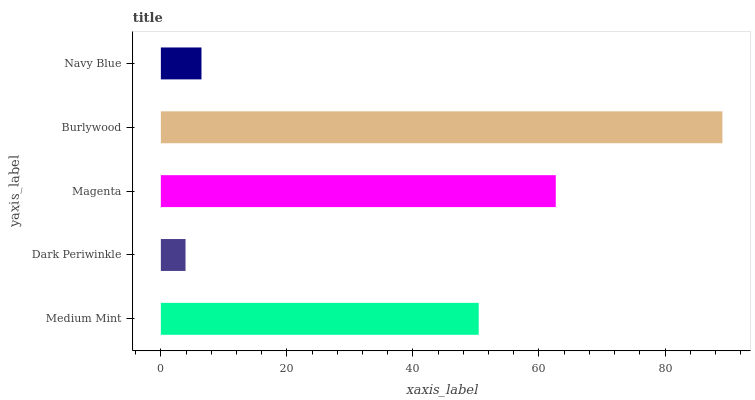Is Dark Periwinkle the minimum?
Answer yes or no. Yes. Is Burlywood the maximum?
Answer yes or no. Yes. Is Magenta the minimum?
Answer yes or no. No. Is Magenta the maximum?
Answer yes or no. No. Is Magenta greater than Dark Periwinkle?
Answer yes or no. Yes. Is Dark Periwinkle less than Magenta?
Answer yes or no. Yes. Is Dark Periwinkle greater than Magenta?
Answer yes or no. No. Is Magenta less than Dark Periwinkle?
Answer yes or no. No. Is Medium Mint the high median?
Answer yes or no. Yes. Is Medium Mint the low median?
Answer yes or no. Yes. Is Burlywood the high median?
Answer yes or no. No. Is Burlywood the low median?
Answer yes or no. No. 